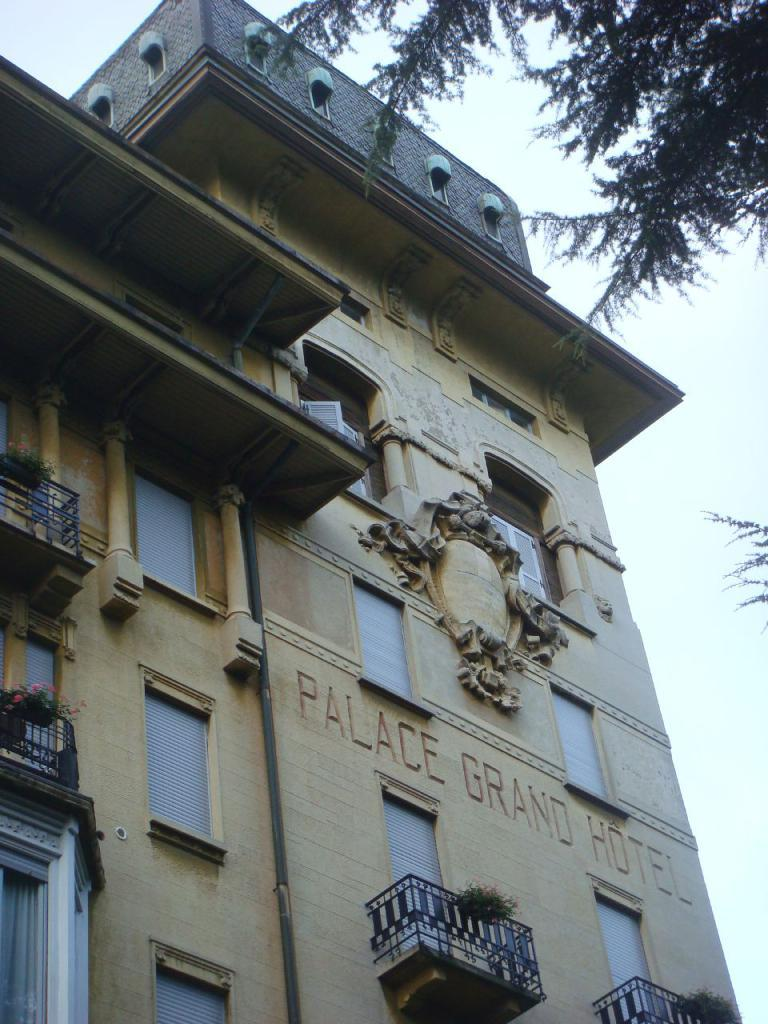What type of structure is present in the image? There is a building in the image. What feature can be seen on the building? The building has windows. What is visible at the top of the image? The sky is visible at the top of the image. What type of vegetation is present in the image? There is a tree in the image. What type of news can be heard coming from the building in the image? There is no indication in the image that news is being broadcast or discussed in the building. 